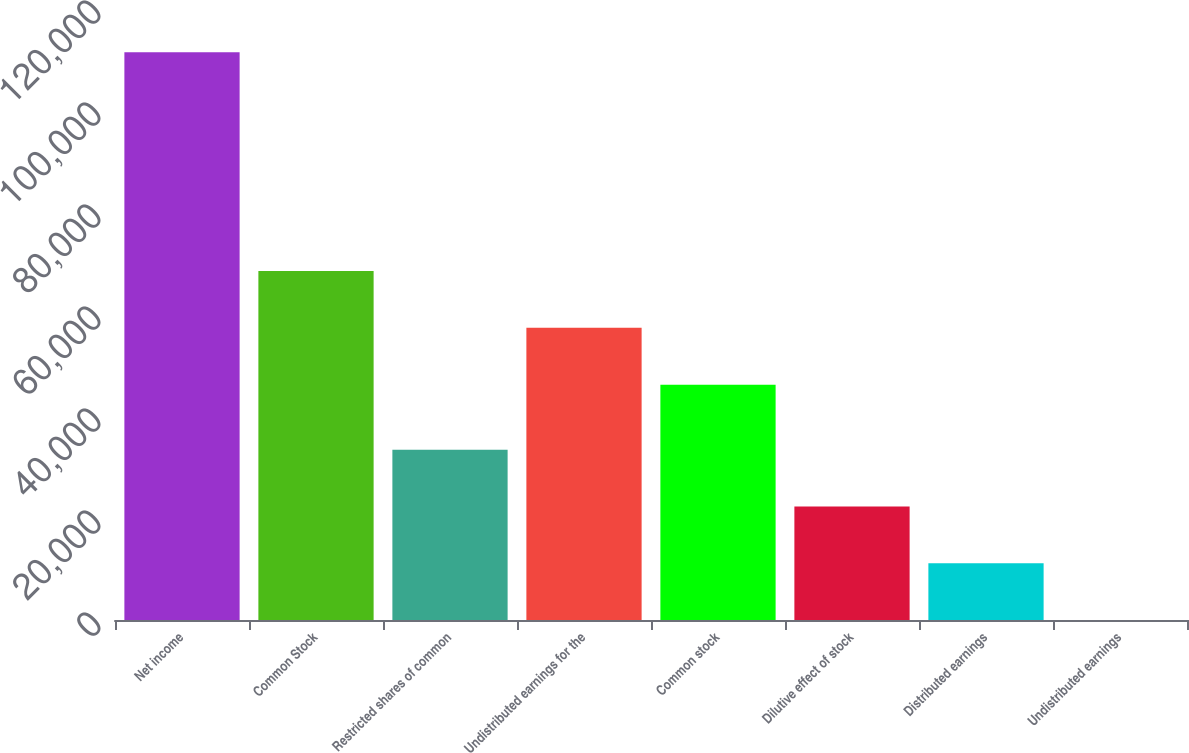<chart> <loc_0><loc_0><loc_500><loc_500><bar_chart><fcel>Net income<fcel>Common Stock<fcel>Restricted shares of common<fcel>Undistributed earnings for the<fcel>Common stock<fcel>Dilutive effect of stock<fcel>Distributed earnings<fcel>Undistributed earnings<nl><fcel>111332<fcel>68416.3<fcel>33399.8<fcel>57283.2<fcel>46150<fcel>22266.7<fcel>11133.5<fcel>0.32<nl></chart> 